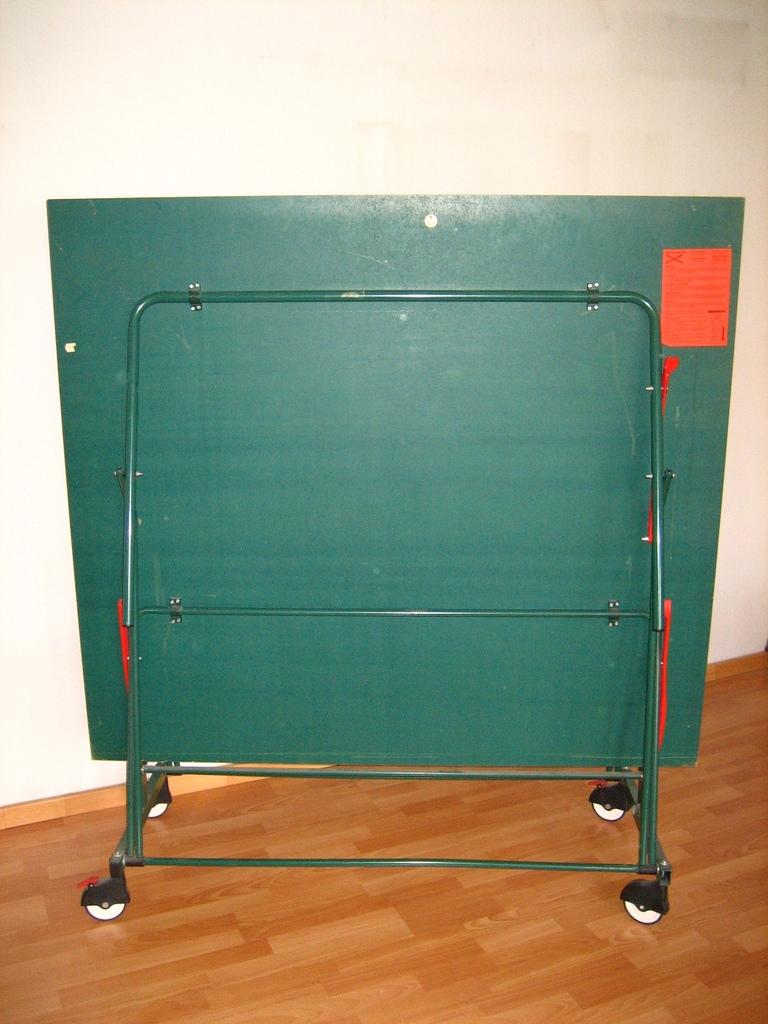Where was the image taken? The image was taken outdoors. What is at the bottom of the image? There is a floor at the bottom of the image. What can be seen in the background of the image? There is a wall in the background of the image. What is the main object in the middle of the image? There is a board on a stand in the middle of the image. What type of pancake is being prepared on the board in the image? There is no pancake present in the image; it features a board on a stand in an outdoor setting. What action is taking place in the image? The image does not depict any specific action; it simply shows a board on a stand in an outdoor setting. 